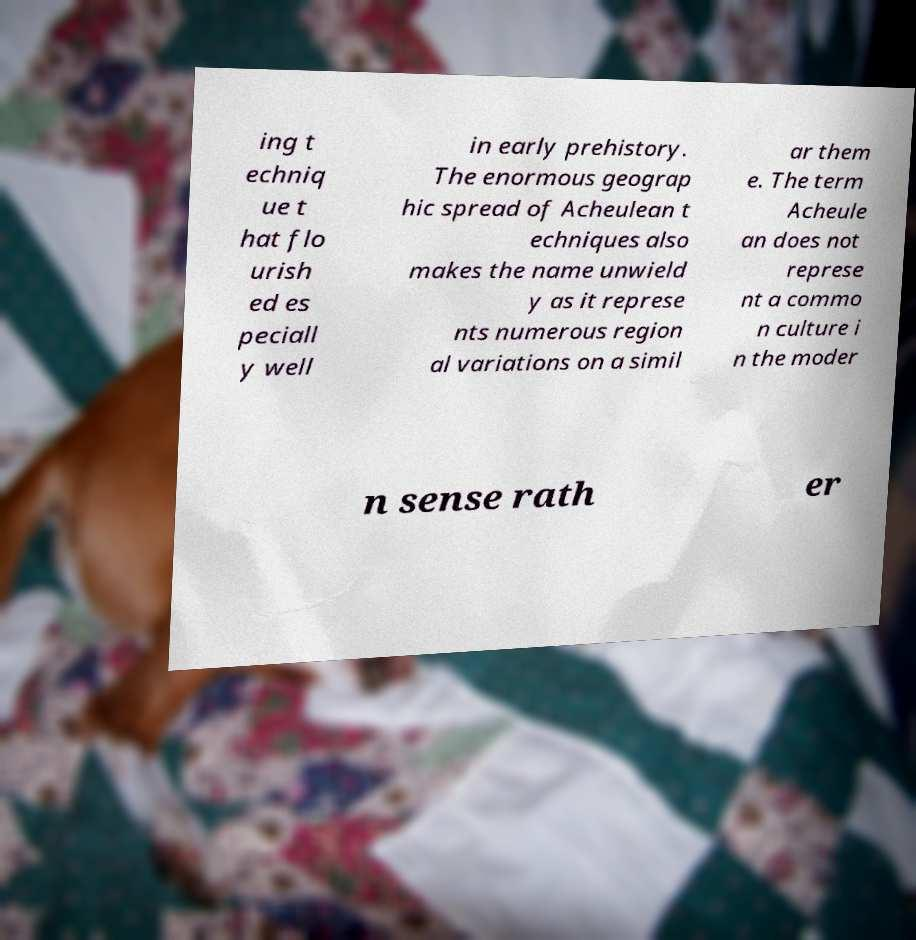Could you extract and type out the text from this image? ing t echniq ue t hat flo urish ed es peciall y well in early prehistory. The enormous geograp hic spread of Acheulean t echniques also makes the name unwield y as it represe nts numerous region al variations on a simil ar them e. The term Acheule an does not represe nt a commo n culture i n the moder n sense rath er 